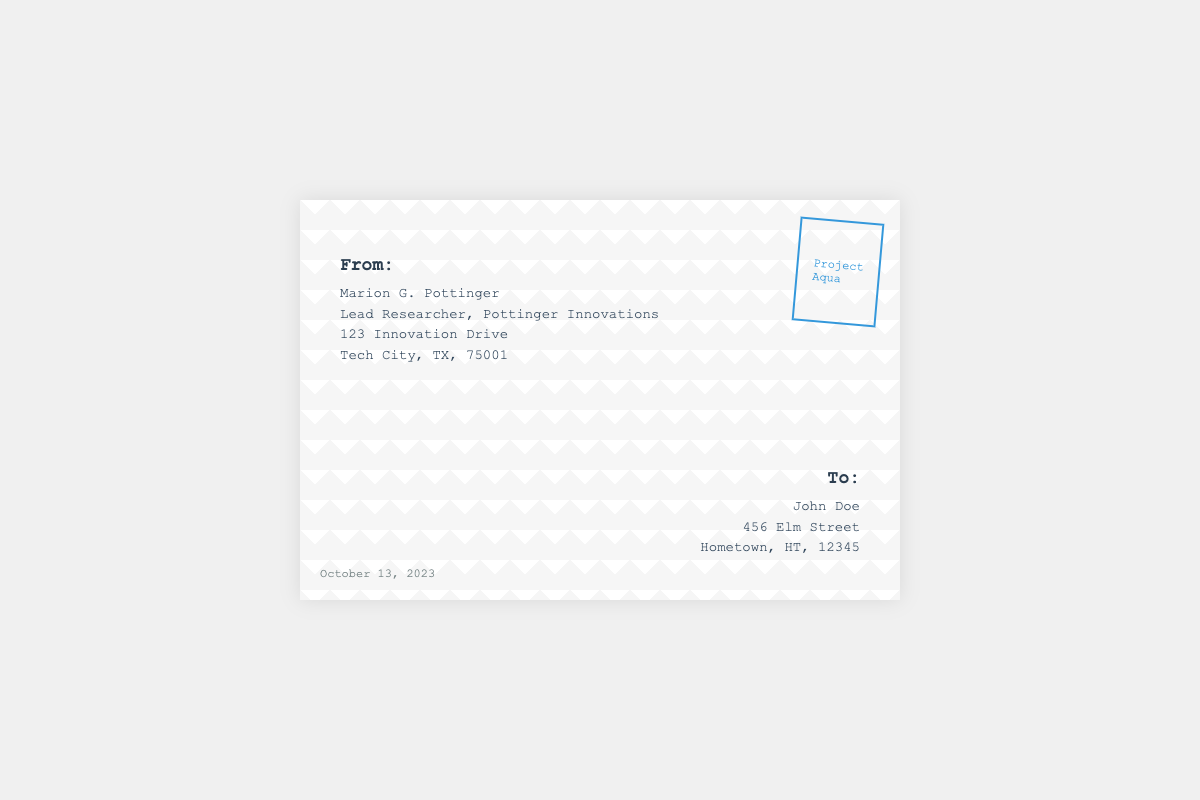what is the name of the sender? The sender is identified as Marion G. Pottinger in the document.
Answer: Marion G. Pottinger what is the sender's title? The title of the sender, Marion G. Pottinger, is mentioned as Lead Researcher.
Answer: Lead Researcher what is the recipient's address? The recipient's address includes specific details that can be found in the document, particularly in the designated area for the recipient.
Answer: 456 Elm Street, Hometown, HT, 12345 what is the date on the envelope? The date that appears on the envelope is specified clearly in the document.
Answer: October 13, 2023 what project is referenced in the stamp? The stamp on the envelope indicates the name of the project mentioned by Marion G. Pottinger.
Answer: Aqua how is the letter structured? The letter is structured with sections for the sender's information, recipient's information, a stamp, and a date, reflecting the typical layout of an envelope.
Answer: Sections who is the recipient of the letter? The name of the person to whom the letter is addressed is found in the recipient section of the envelope.
Answer: John Doe from which organization does the sender come? The document specifies that the sender is associated with Pottinger Innovations.
Answer: Pottinger Innovations what city is the sender located in? The city mentioned in the sender's address provides the location where Marion G. Pottinger is based.
Answer: Tech City 